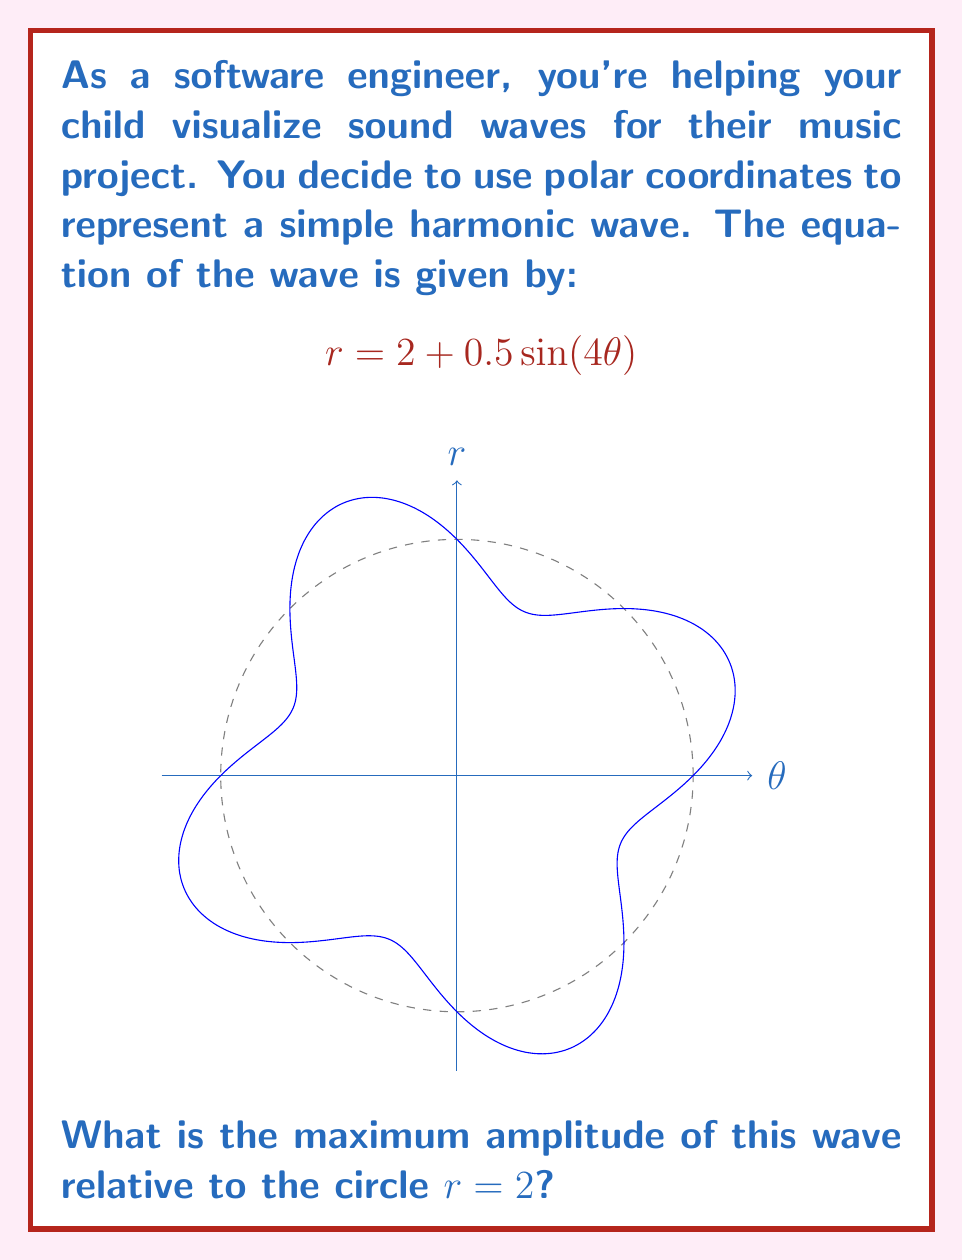Can you solve this math problem? Let's approach this step-by-step:

1) The equation $r = 2 + 0.5 \sin(4\theta)$ represents a polar curve where:
   - The base circle has a radius of 2
   - The sine term $0.5 \sin(4\theta)$ causes the wave to oscillate around this circle

2) The amplitude of the wave is determined by the coefficient of the sine term, which is 0.5.

3) This means that the wave oscillates 0.5 units above and below the circle $r = 2$.

4) To find the maximum amplitude relative to the circle $r = 2$, we need to consider both the positive and negative peaks:
   - Maximum outward amplitude: $0.5$ units
   - Maximum inward amplitude: $0.5$ units

5) The total peak-to-peak amplitude is therefore $0.5 + 0.5 = 1$ unit.

6) However, the question asks for the maximum amplitude, which is half of the peak-to-peak amplitude.

Therefore, the maximum amplitude relative to the circle $r = 2$ is $0.5$ units.
Answer: $0.5$ units 